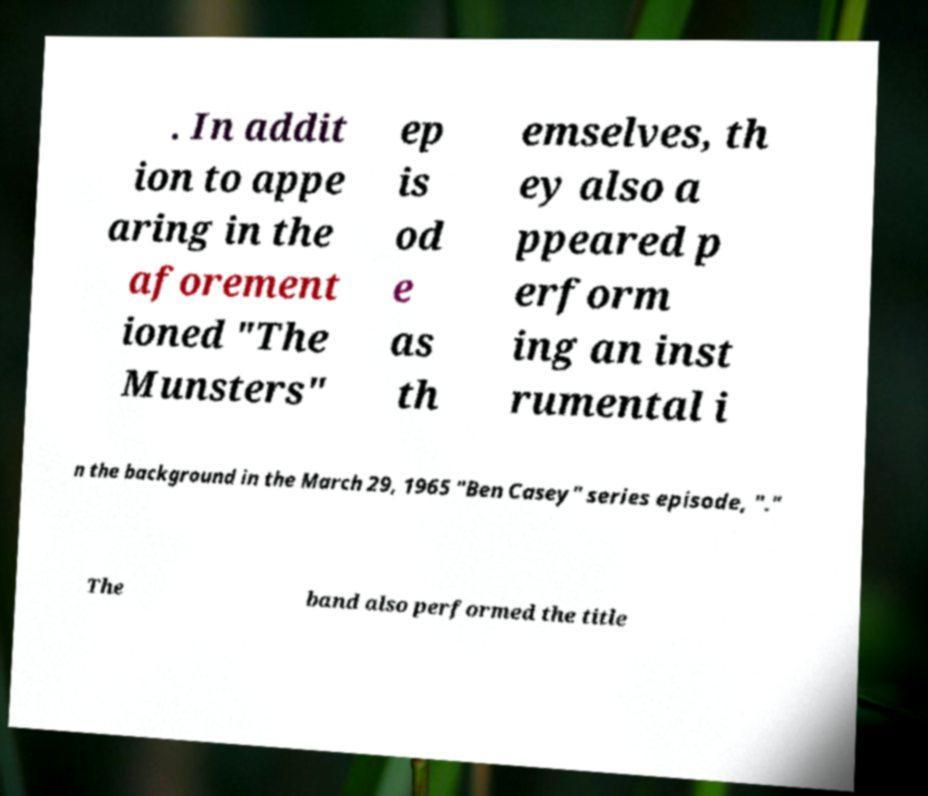For documentation purposes, I need the text within this image transcribed. Could you provide that? . In addit ion to appe aring in the aforement ioned "The Munsters" ep is od e as th emselves, th ey also a ppeared p erform ing an inst rumental i n the background in the March 29, 1965 "Ben Casey" series episode, "." The band also performed the title 